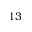<formula> <loc_0><loc_0><loc_500><loc_500>1 3</formula> 